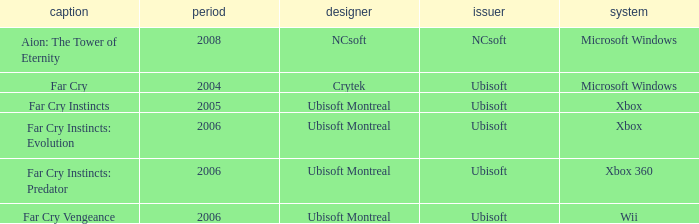What is the average year that has far cry vengeance as the title? 2006.0. 